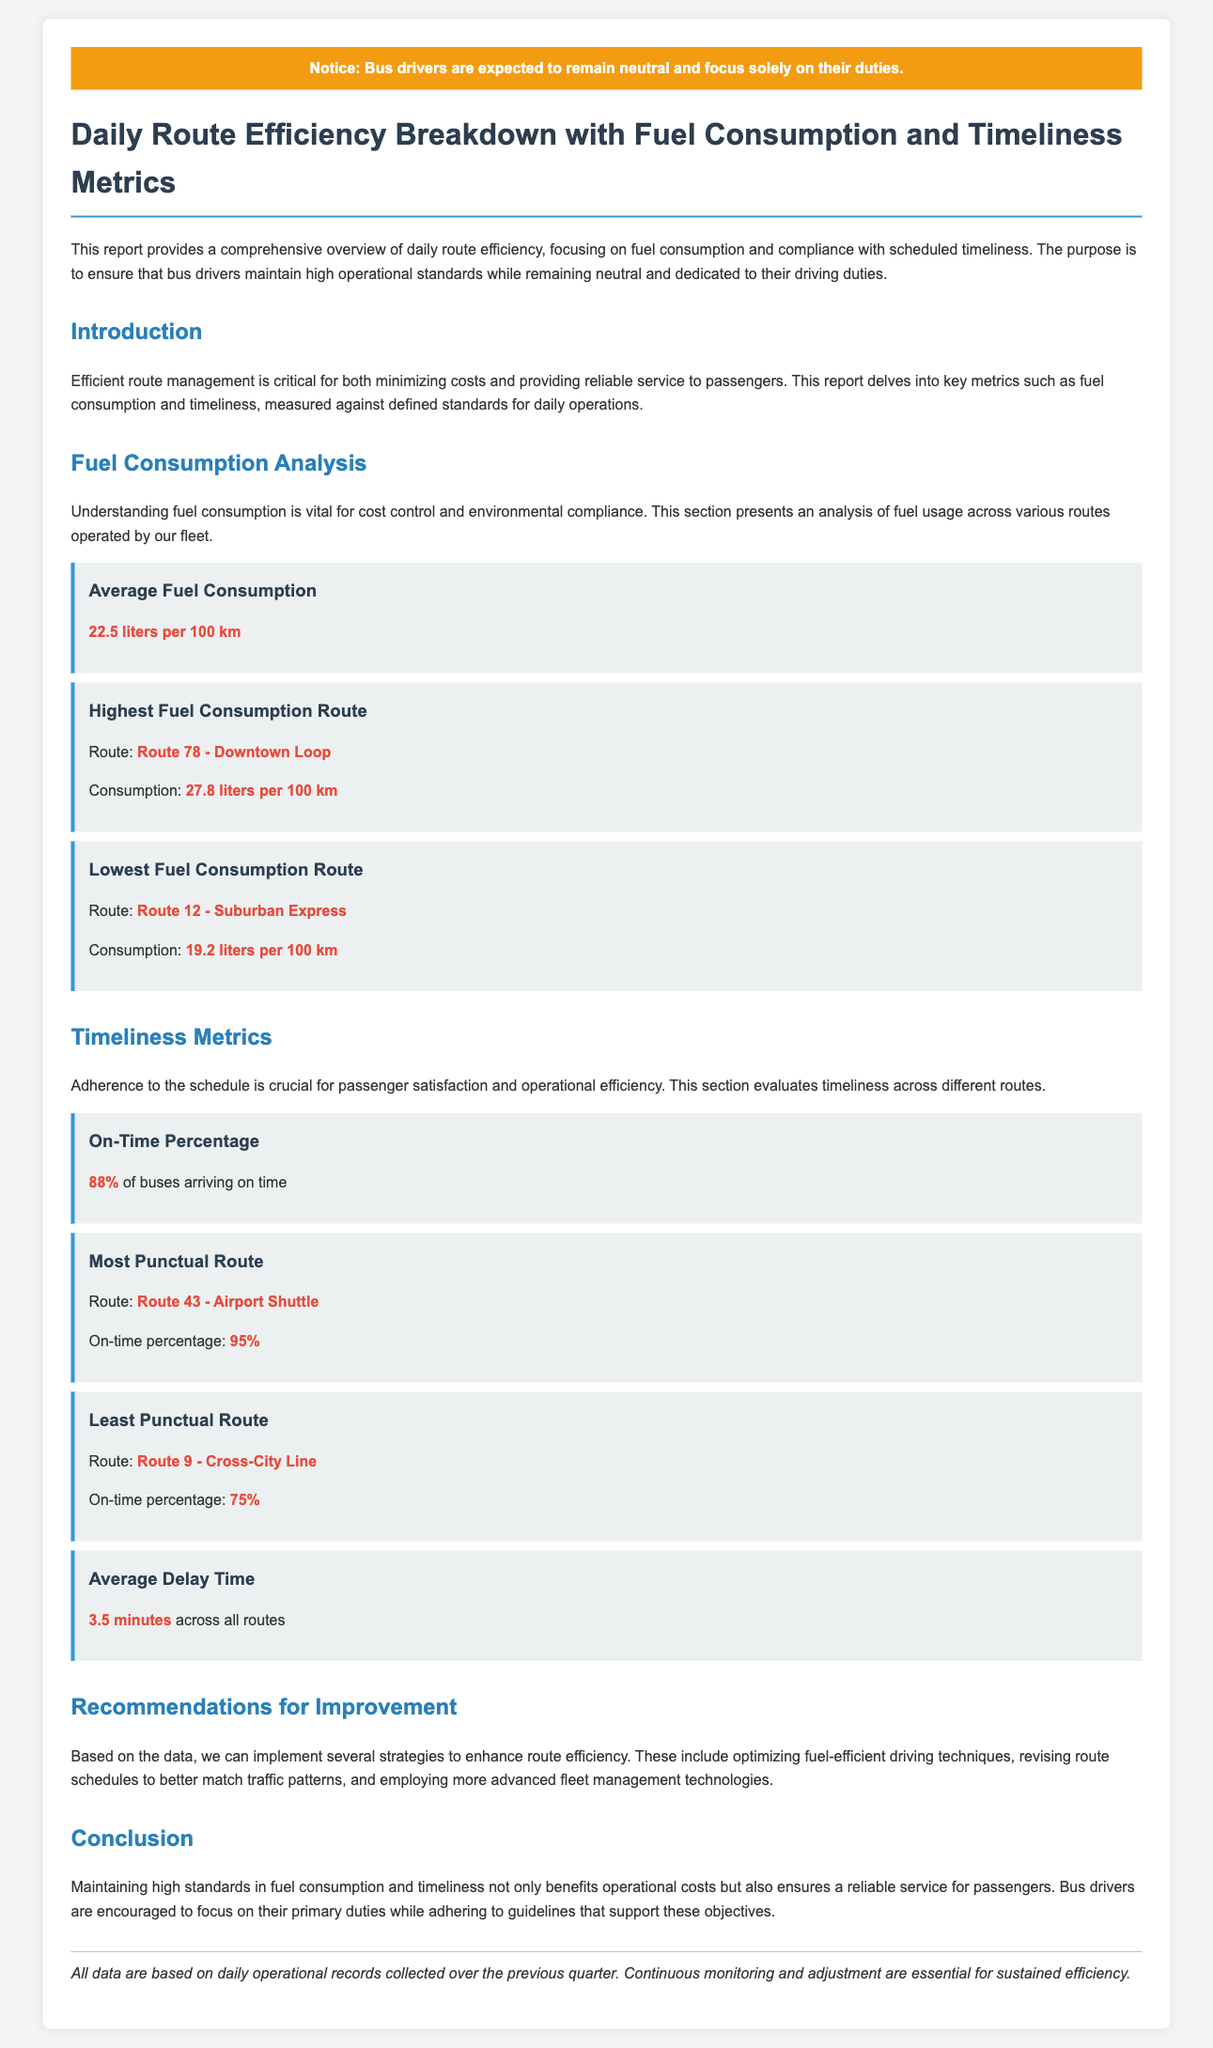What is the average fuel consumption? The average fuel consumption is highlighted in the fuel consumption analysis section as 22.5 liters per 100 km.
Answer: 22.5 liters per 100 km Which route has the highest fuel consumption? The document specifies the highest fuel consumption route as Route 78 - Downtown Loop with a consumption of 27.8 liters per 100 km.
Answer: Route 78 - Downtown Loop What is the on-time percentage of buses? The on-time percentage is stated in the timeliness metrics section as 88%.
Answer: 88% Which route is the most punctual? The most punctual route is mentioned as Route 43 - Airport Shuttle with an on-time percentage of 95%.
Answer: Route 43 - Airport Shuttle What is the average delay time across all routes? The average delay time is provided as 3.5 minutes in the timeliness metrics section.
Answer: 3.5 minutes What recommendation is made for improving route efficiency? The recommendations section suggests implementing strategies like optimizing fuel-efficient driving techniques.
Answer: Optimizing fuel-efficient driving techniques How is the report structured? The report is structured into sections such as Introduction, Fuel Consumption Analysis, Timeliness Metrics, Recommendations for Improvement, and Conclusion.
Answer: Sections include Introduction, Fuel Consumption Analysis, Timeliness Metrics, Recommendations, Conclusion What notice is given to bus drivers? The notice indicates that bus drivers are expected to remain neutral and focus solely on their duties.
Answer: Remain neutral and focus solely on their duties 